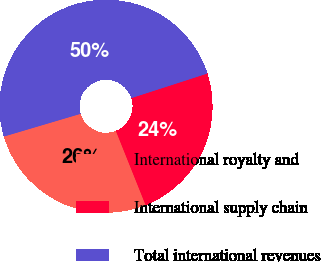Convert chart. <chart><loc_0><loc_0><loc_500><loc_500><pie_chart><fcel>International royalty and<fcel>International supply chain<fcel>Total international revenues<nl><fcel>26.48%<fcel>23.91%<fcel>49.61%<nl></chart> 